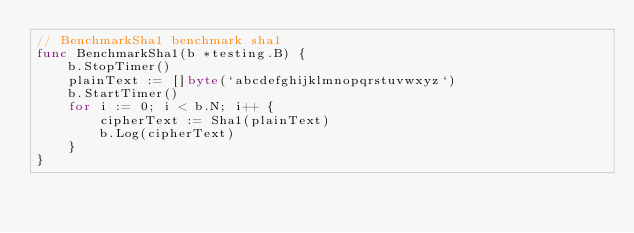Convert code to text. <code><loc_0><loc_0><loc_500><loc_500><_Go_>// BenchmarkSha1 benchmark sha1
func BenchmarkSha1(b *testing.B) {
	b.StopTimer()
	plainText := []byte(`abcdefghijklmnopqrstuvwxyz`)
	b.StartTimer()
	for i := 0; i < b.N; i++ {
		cipherText := Sha1(plainText)
		b.Log(cipherText)
	}
}
</code> 